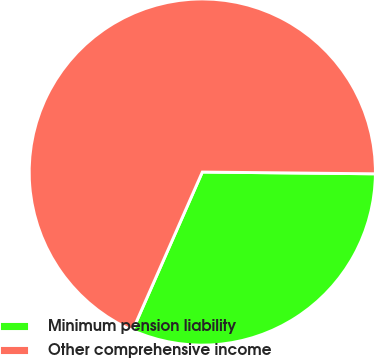Convert chart to OTSL. <chart><loc_0><loc_0><loc_500><loc_500><pie_chart><fcel>Minimum pension liability<fcel>Other comprehensive income<nl><fcel>31.44%<fcel>68.56%<nl></chart> 